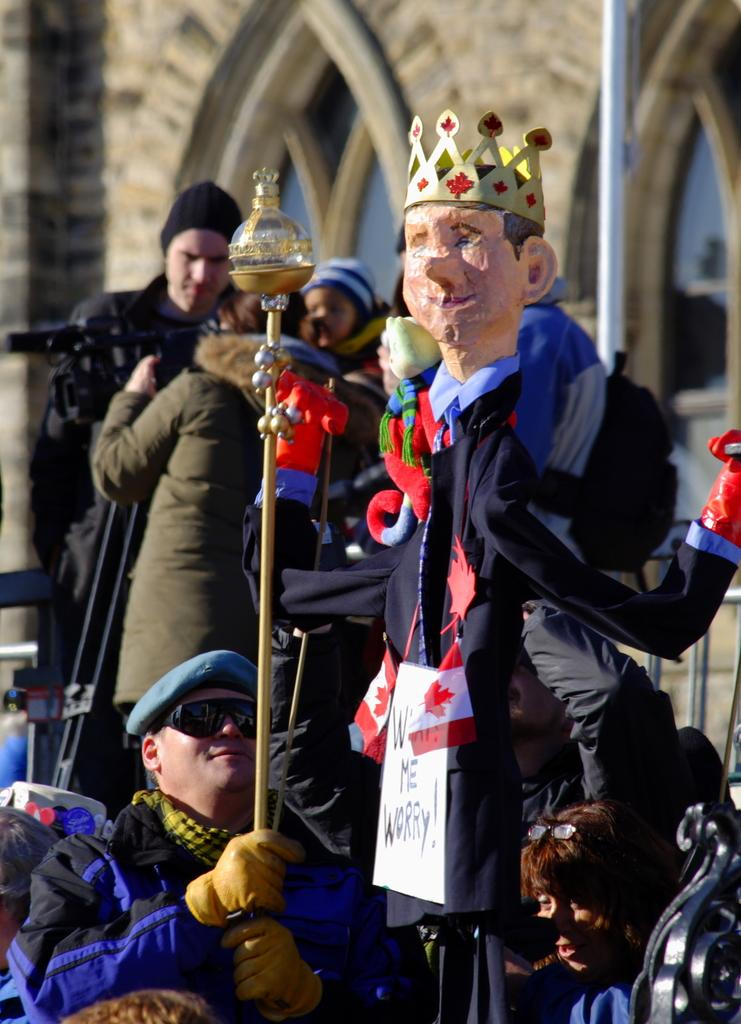What is the main subject in the image? There is a statue in the image. What else can be seen in the image besides the statue? There is a pole, people, objects, and a wall with windows in the background of the image. Can you describe the people in the image? There are people in the image, but their specific actions or characteristics are not mentioned in the provided facts. What is the setting of the image? The image features a statue, a pole, and a wall with windows in the background, suggesting an outdoor or public setting. How many items are being sold at the market in the image? There is no market present in the image, so it is not possible to determine how many items are being sold. 